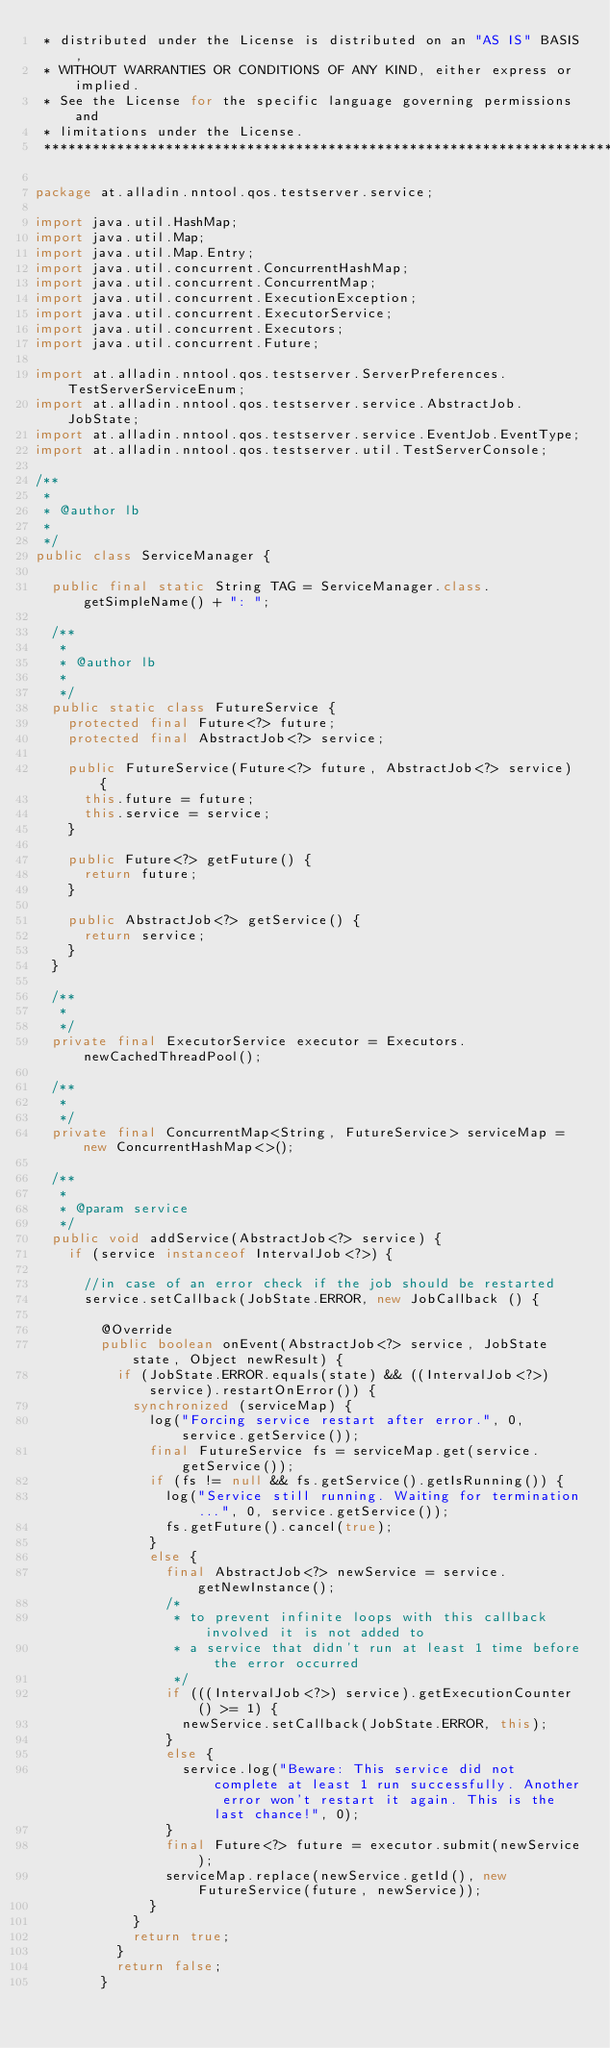<code> <loc_0><loc_0><loc_500><loc_500><_Java_> * distributed under the License is distributed on an "AS IS" BASIS,
 * WITHOUT WARRANTIES OR CONDITIONS OF ANY KIND, either express or implied.
 * See the License for the specific language governing permissions and
 * limitations under the License.
 ******************************************************************************/

package at.alladin.nntool.qos.testserver.service;

import java.util.HashMap;
import java.util.Map;
import java.util.Map.Entry;
import java.util.concurrent.ConcurrentHashMap;
import java.util.concurrent.ConcurrentMap;
import java.util.concurrent.ExecutionException;
import java.util.concurrent.ExecutorService;
import java.util.concurrent.Executors;
import java.util.concurrent.Future;

import at.alladin.nntool.qos.testserver.ServerPreferences.TestServerServiceEnum;
import at.alladin.nntool.qos.testserver.service.AbstractJob.JobState;
import at.alladin.nntool.qos.testserver.service.EventJob.EventType;
import at.alladin.nntool.qos.testserver.util.TestServerConsole;

/**
 * 
 * @author lb
 *
 */
public class ServiceManager {
	
	public final static String TAG = ServiceManager.class.getSimpleName() + ": ";

	/**
	 * 
	 * @author lb
	 *
	 */
	public static class FutureService {
		protected final Future<?> future;
		protected final AbstractJob<?> service;
		
		public FutureService(Future<?> future, AbstractJob<?> service) {
			this.future = future;
			this.service = service;
		}

		public Future<?> getFuture() {
			return future;
		}

		public AbstractJob<?> getService() {
			return service;
		}
	}
	
	/**
	 * 
	 */
	private final ExecutorService executor = Executors.newCachedThreadPool();
	
	/**
	 * 
	 */
	private final ConcurrentMap<String, FutureService> serviceMap = new ConcurrentHashMap<>();
	
	/**
	 * 
	 * @param service
	 */
	public void addService(AbstractJob<?> service) {
		if (service instanceof IntervalJob<?>) {

			//in case of an error check if the job should be restarted
			service.setCallback(JobState.ERROR, new JobCallback () {
				
				@Override
				public boolean onEvent(AbstractJob<?> service, JobState state, Object newResult) {
					if (JobState.ERROR.equals(state) && ((IntervalJob<?>) service).restartOnError()) {
						synchronized (serviceMap) {
							log("Forcing service restart after error.", 0, service.getService());
							final FutureService fs = serviceMap.get(service.getService());
							if (fs != null && fs.getService().getIsRunning()) {
								log("Service still running. Waiting for termination...", 0, service.getService());
								fs.getFuture().cancel(true);
							}
							else {					
								final AbstractJob<?> newService = service.getNewInstance();
								/*
								 * to prevent infinite loops with this callback involved it is not added to 
								 * a service that didn't run at least 1 time before the error occurred 
								 */
								if (((IntervalJob<?>) service).getExecutionCounter() >= 1) {
									newService.setCallback(JobState.ERROR, this);
								}
								else {
									service.log("Beware: This service did not complete at least 1 run successfully. Another error won't restart it again. This is the last chance!", 0);
								}
								final Future<?> future = executor.submit(newService);
								serviceMap.replace(newService.getId(), new FutureService(future, newService));
							}
						}
						return true;
					}
					return false;
				}</code> 